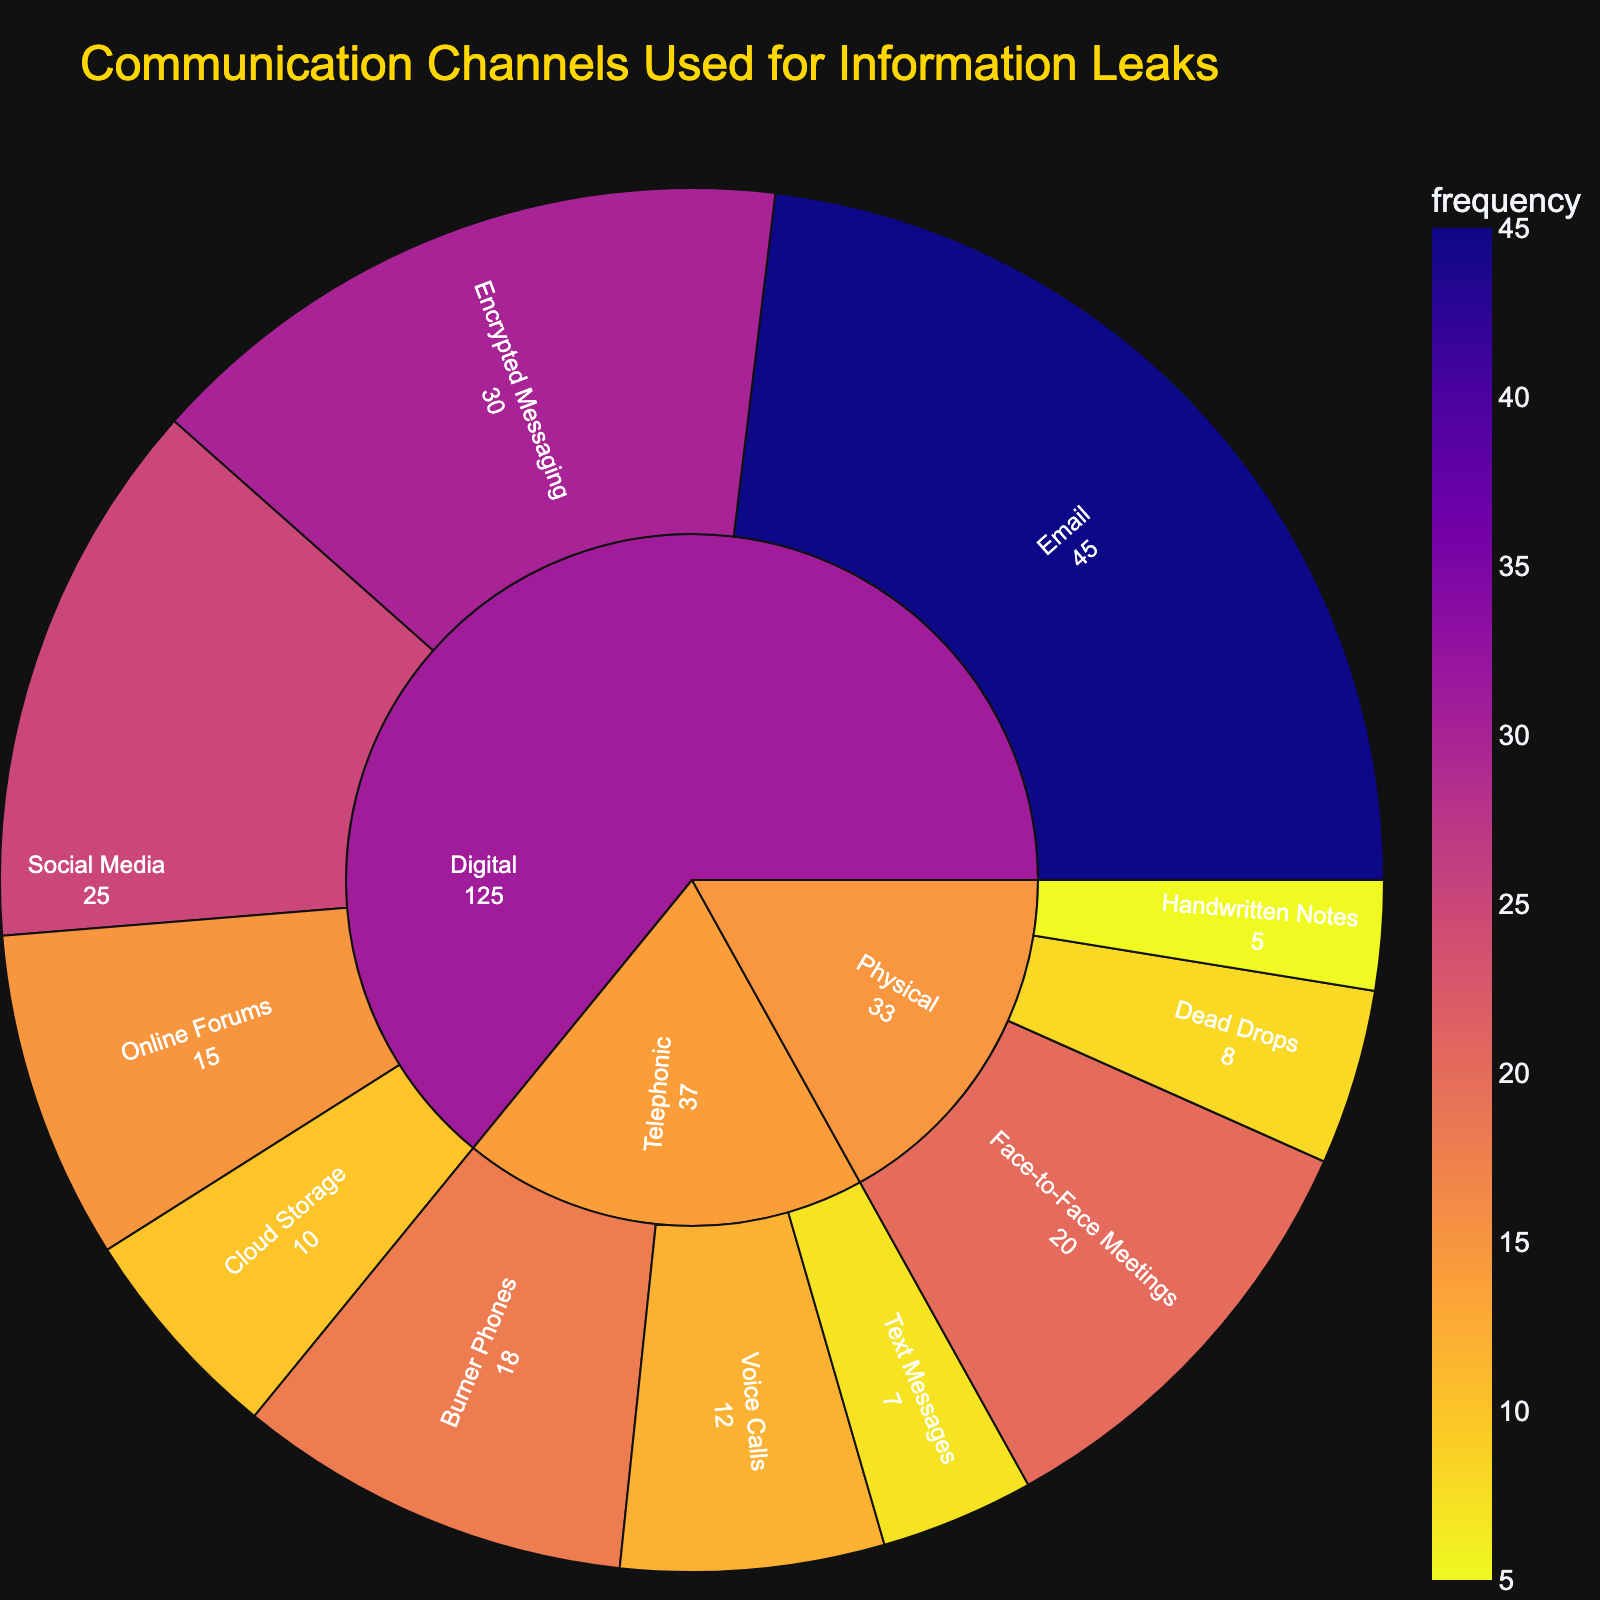what is the title of the figure? The title is usually displayed prominently at the top of the figure. It summarizes what the plot is about. Here, the title helps the viewer understand that the diagram is focused on how information leaks through various communication channels.
Answer: Communication Channels Used for Information Leaks Which platform uses hand-written notes for leaking information? The sunburst plot breaks down the platforms into specific channels. By finding 'Handwritten Notes', we can trace it back to its parent 'Physical' platform.
Answer: Physical What is the total frequency of leaks for physical channels? The individual frequencies for the physical channels are 'Face-to-Face Meetings' (20), 'Dead Drops' (8), and 'Handwritten Notes' (5). Summing these gives 20 + 8 + 5 = 33.
Answer: 33 Which channel has the highest frequency of use? The outer rings display the individual channels and their corresponding frequencies. By identifying the channel with the highest number, we find it is 'Email' with a frequency of 45.
Answer: Email Which platform has the least overall frequency of leaks? To find this, calculate the total frequency for each platform. Summing the frequencies for 'Digital', 'Physical', and 'Telephonic', we compare these totals. 'Physical' has the lowest total frequency (33).
Answer: Physical Are encrypted messaging services used more frequently than burner phones? Compare the frequency values directly. Encrypted Messaging has a frequency of 30, while Burner Phones have a frequency of 18.
Answer: Yes What is the difference in frequency between the most and least used digital channels? The most used digital channel is 'Email' (45), and the least used is 'Cloud Storage' (10). The difference is 45 - 10 = 35.
Answer: 35 Does the digital platform have a higher sum of frequencies than the telephonic platform? Sum the frequencies for 'Digital' and 'Telephonic' platforms. Digital is 45 + 30 + 25 + 15 + 10 = 125. Telephonic is 18 + 12 + 7 = 37. Compare the sums.
Answer: Yes How many channels are used for the telephonic platform? Count the individual channels listed under the 'Telephonic' platform in the sunburst plot. These are 'Burner Phones', 'Voice Calls', and 'Text Messages', totaling 3 channels.
Answer: 3 